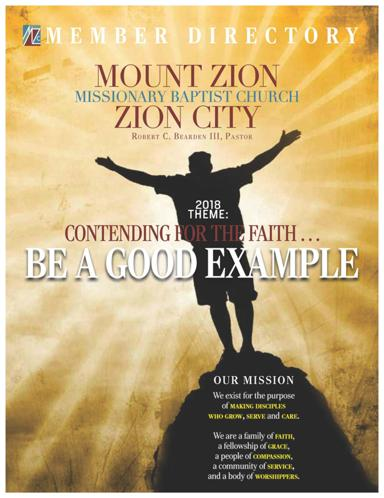What is the theme for the church for the year 2018? The theme for the Mount Zion Missionary Baptist Church for the year 2018 is 'Contending for the Faith - Be A Good Example.' This theme focuses on upholding and exemplifying strong faith values. 